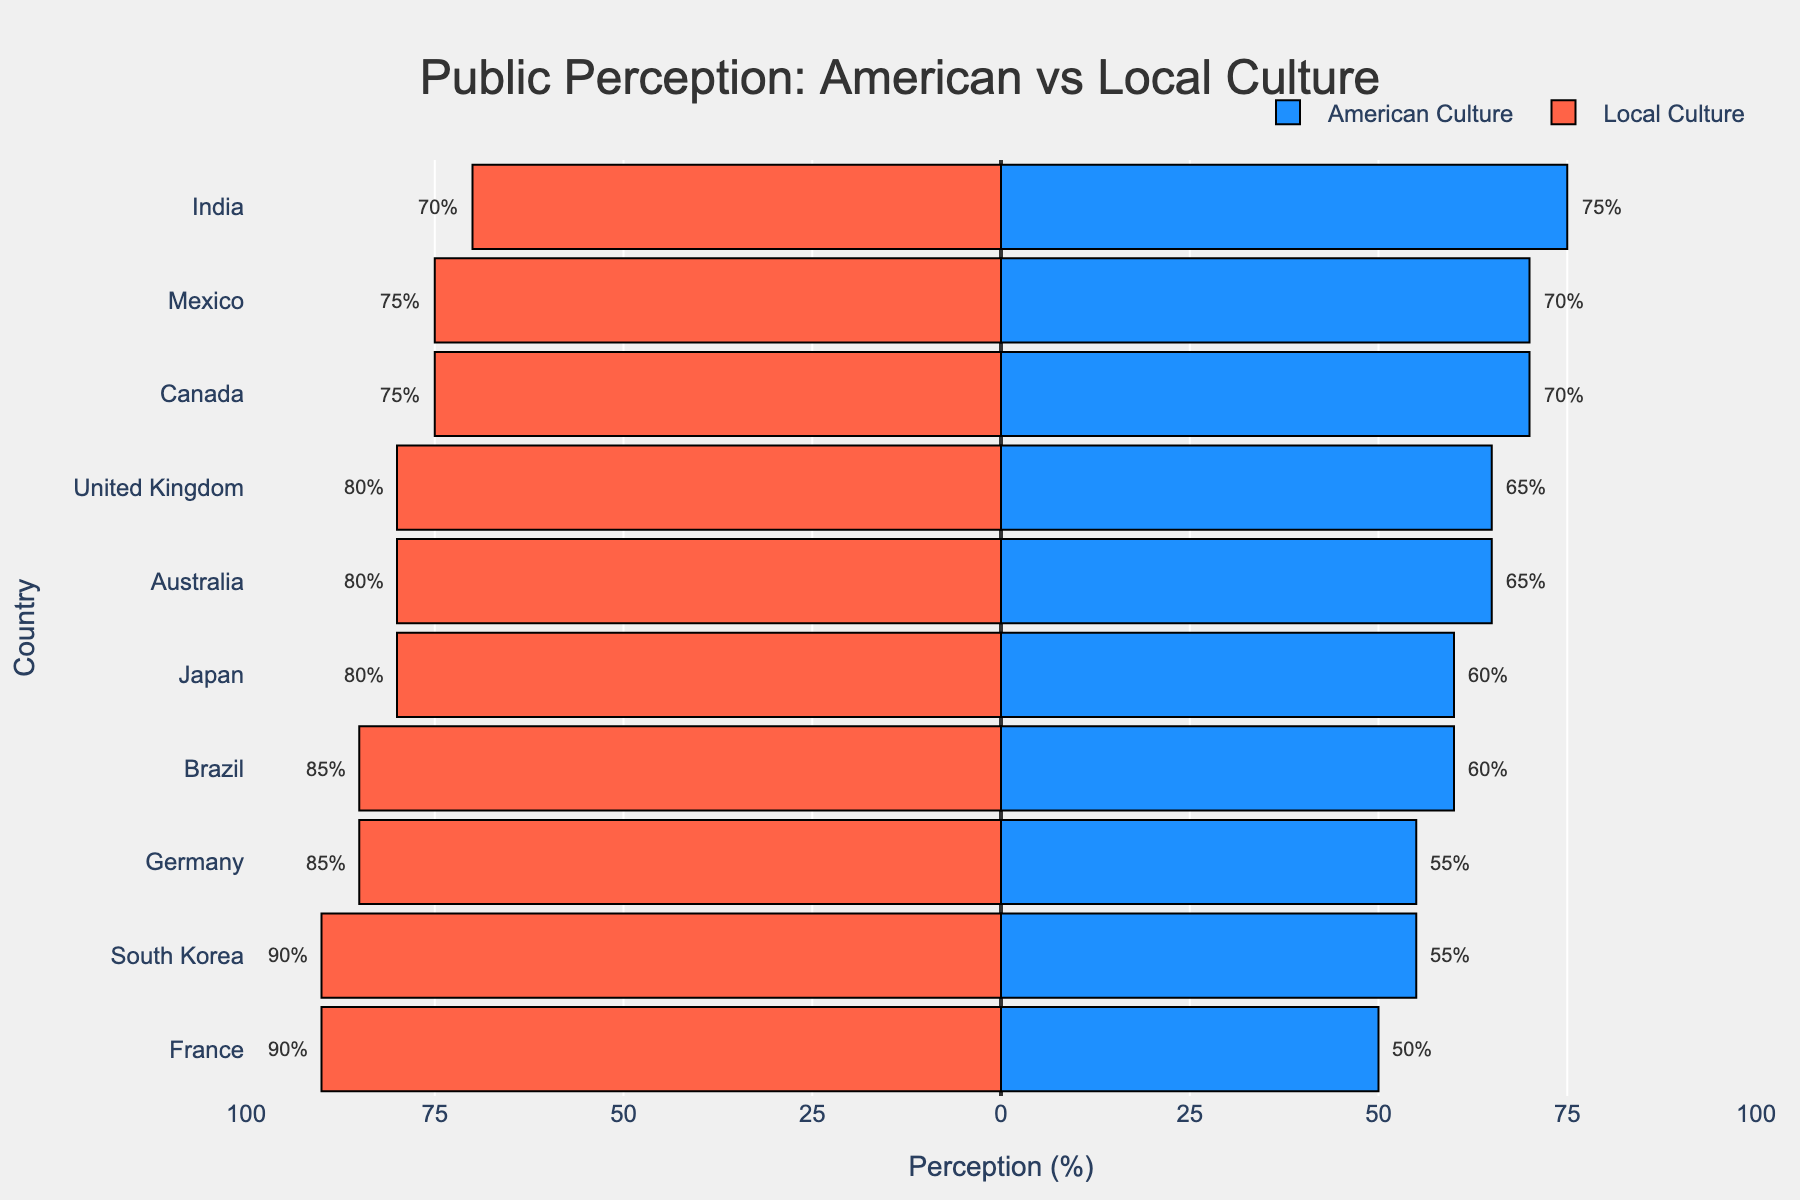What's the average public perception of American culture across all countries? To find the average, add the public perception percentages of American culture for all the countries and divide by the number of countries: (65 + 60 + 70 + 50 + 55 + 75 + 60 + 70 + 55 + 65) / 10 = 62.5
Answer: 62.5 Which country has the highest public perception of local culture? Locate the bar representing the perception of local culture that extends furthest to the left. This is France with a value of 90%.
Answer: France What is the difference in public perception of American culture and local culture in Australia? Subtract the public perception of American culture from the local culture: 80 - 65 = 15
Answer: 15 Compare the public perception of American culture between Canada and Mexico. Look at the length of the blue bars for both countries. Canada has 70%, and Mexico also has 70%.
Answer: They are equal Which country has the smallest difference between public perception of American and local culture? Calculate the difference for each country and find the smallest. Canada's difference is 70 - 75 = -5, which is the smallest difference (in absolute value).
Answer: Canada What is the total public perception percentage (American + Local) for India? Add the public perception percentages of American and local culture for India: 75 + 70 = 145
Answer: 145 How many countries have a higher public perception of local culture compared to American culture? Count the countries where the red bar (local culture) extends further to the left than the blue bar (American culture). There are 7 such countries (Australia, Brazil, France, Germany, Japan, South Korea, United Kingdom).
Answer: 7 What's the average public perception of local culture across all countries? Add up the public perception percentages of local culture for all the countries and divide by the number of countries: (80 + 85 + 75 + 90 + 85 + 70 + 80 + 75 + 90 + 80) / 10 = 81
Answer: 81 Which country perceives American culture more positively, India or Germany? Compare the length of the blue bars for both countries. India has a perception of 75%, while Germany has 55%. Therefore, India perceives American culture more positively.
Answer: India 